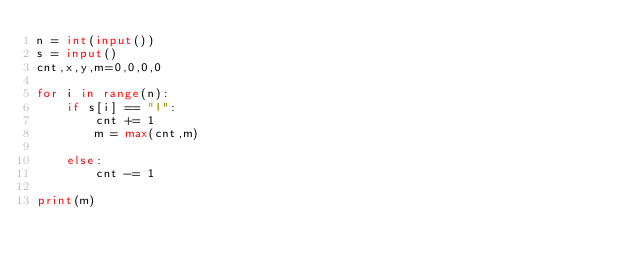<code> <loc_0><loc_0><loc_500><loc_500><_Python_>n = int(input())
s = input()
cnt,x,y,m=0,0,0,0

for i in range(n):
    if s[i] == "I":
        cnt += 1
        m = max(cnt,m)

    else:
        cnt -= 1

print(m)</code> 